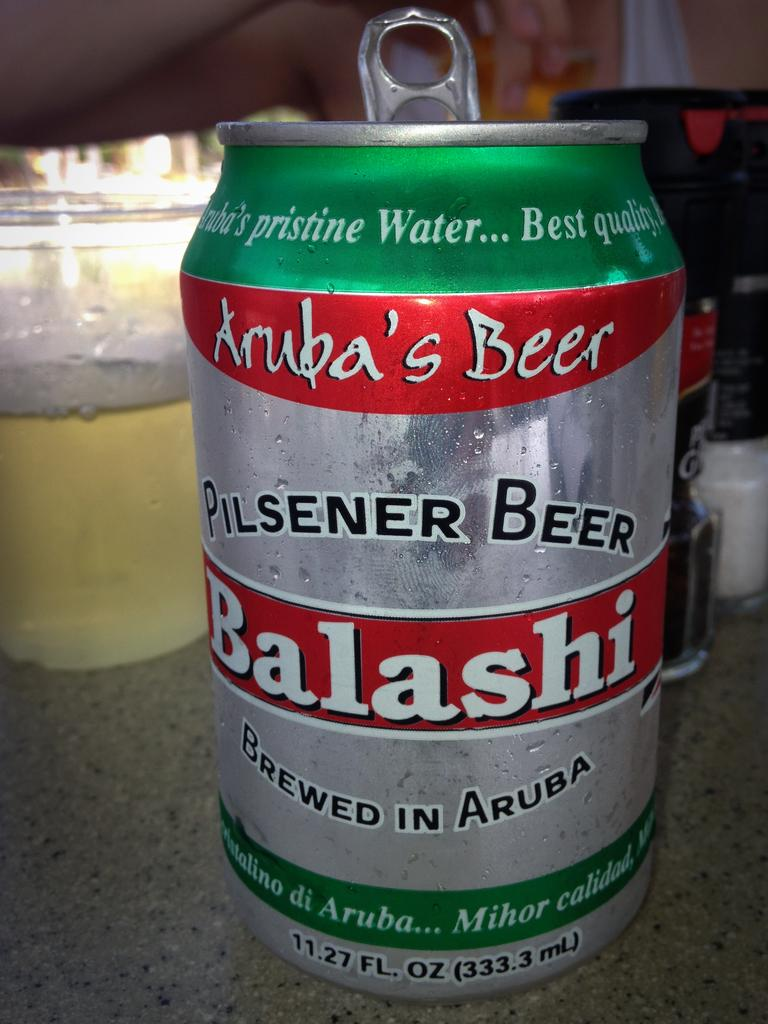Provide a one-sentence caption for the provided image. A silver, green , and red  can of Pilsener beer  brewed in Aruba. 